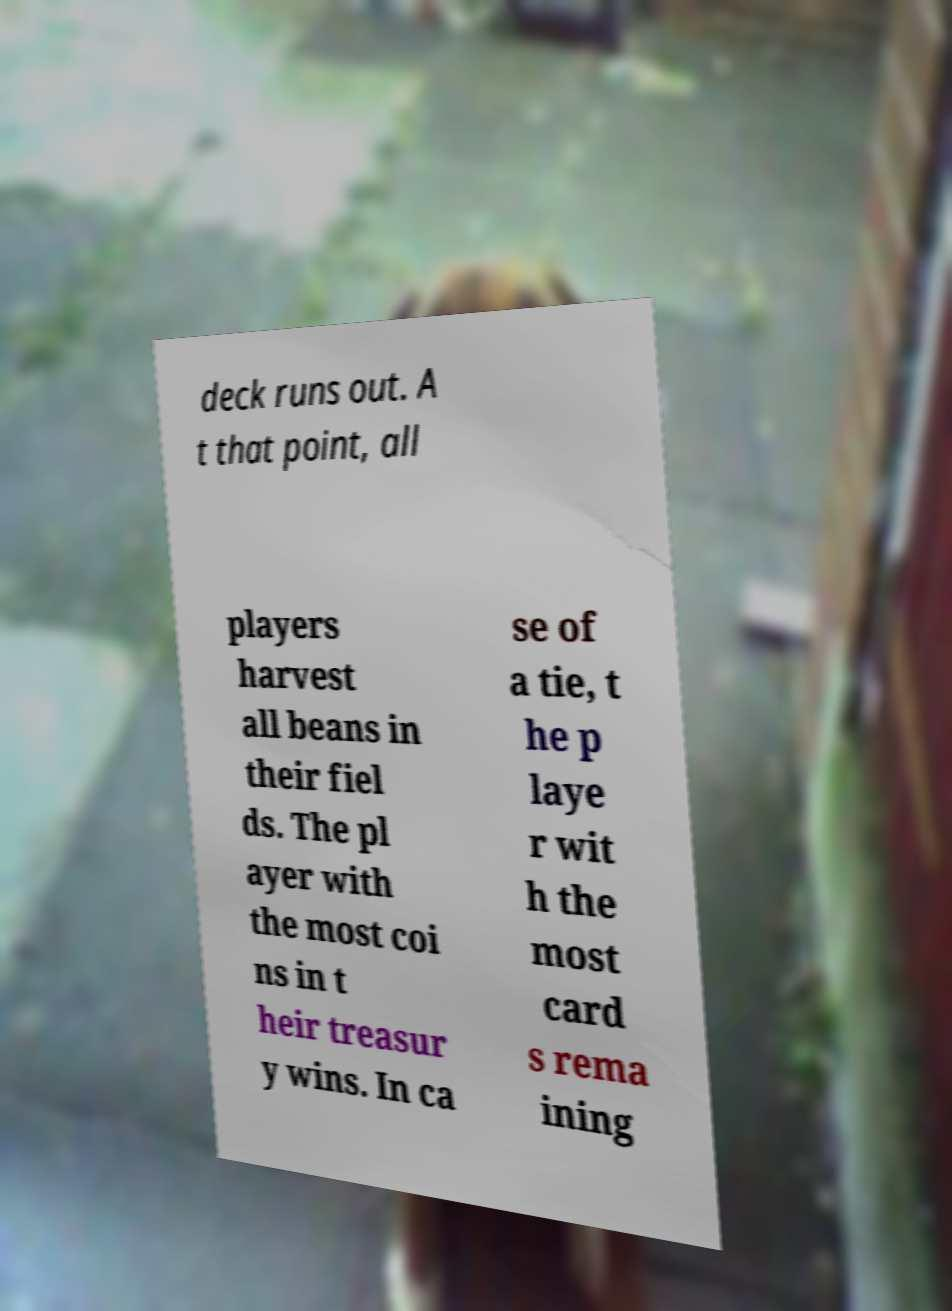I need the written content from this picture converted into text. Can you do that? deck runs out. A t that point, all players harvest all beans in their fiel ds. The pl ayer with the most coi ns in t heir treasur y wins. In ca se of a tie, t he p laye r wit h the most card s rema ining 